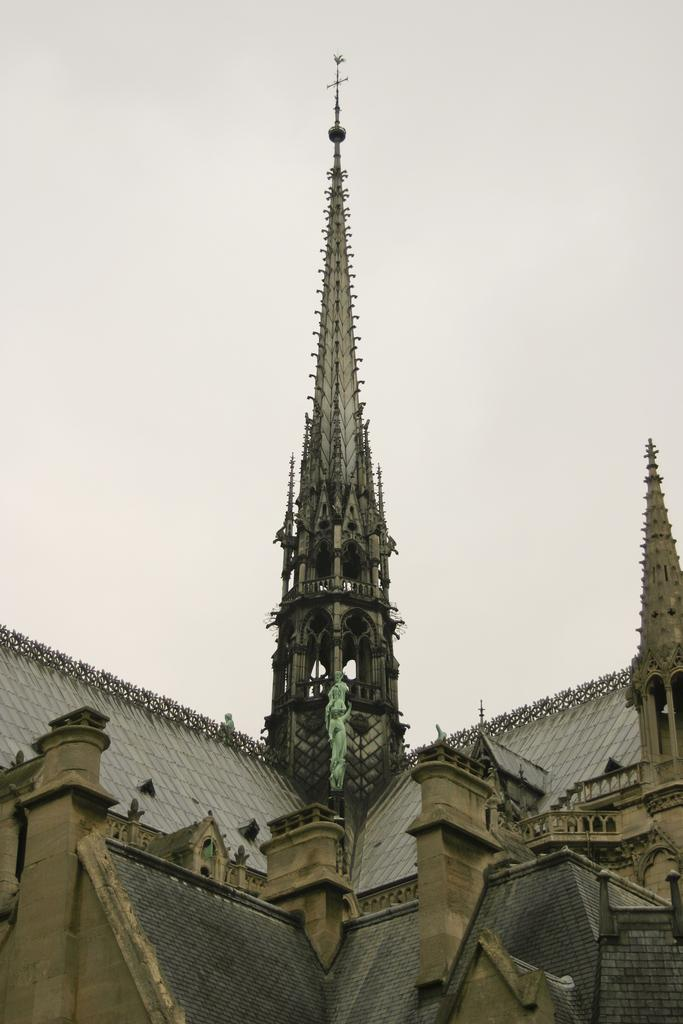What is the main structure in the center of the image? There is a tower in the center of the image. What other structures can be seen in the image? There are buildings in the image. What can be seen in the background of the image? The sky is visible in the background of the image. What type of apparel is the tower wearing in the image? The tower is not a living being and therefore cannot wear apparel. 